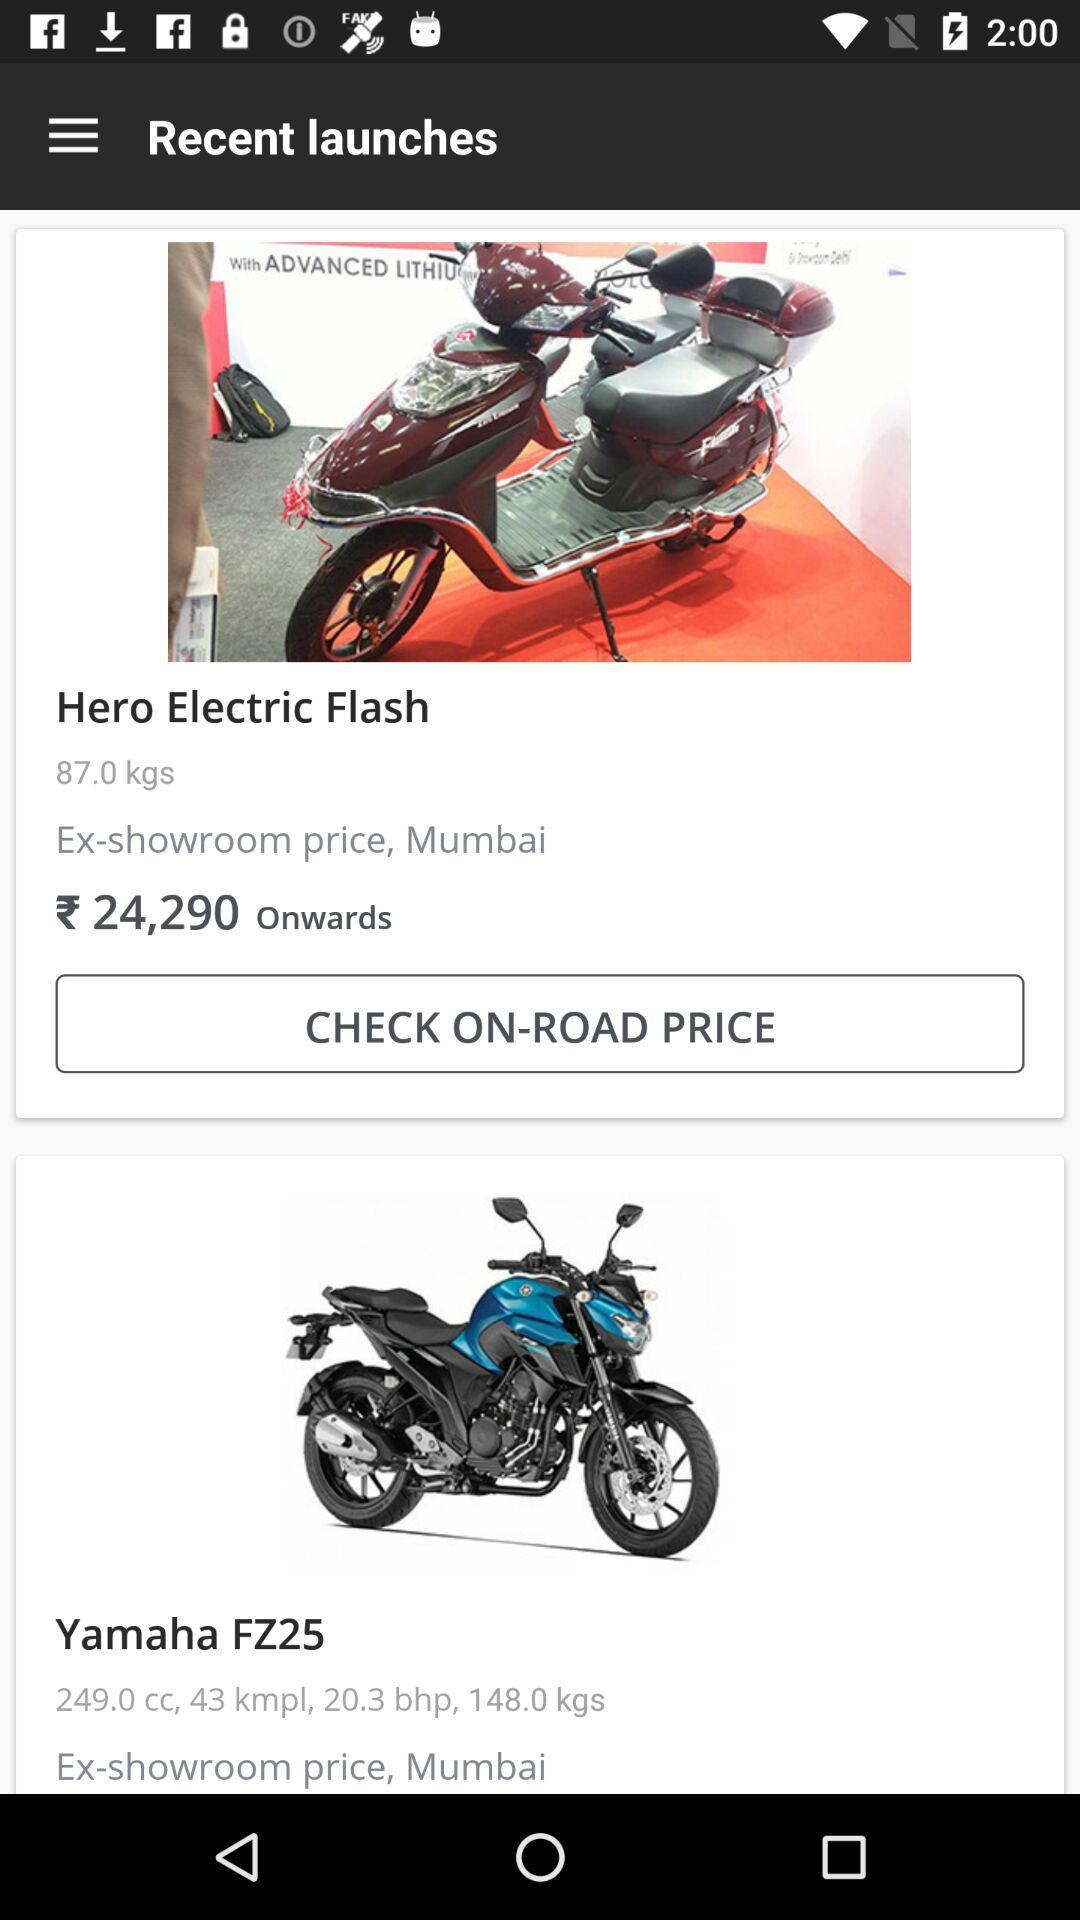How much does a "Hero Electric Flash" motorcycle weigh in pounds and ounces?
When the provided information is insufficient, respond with <no answer>. <no answer> 